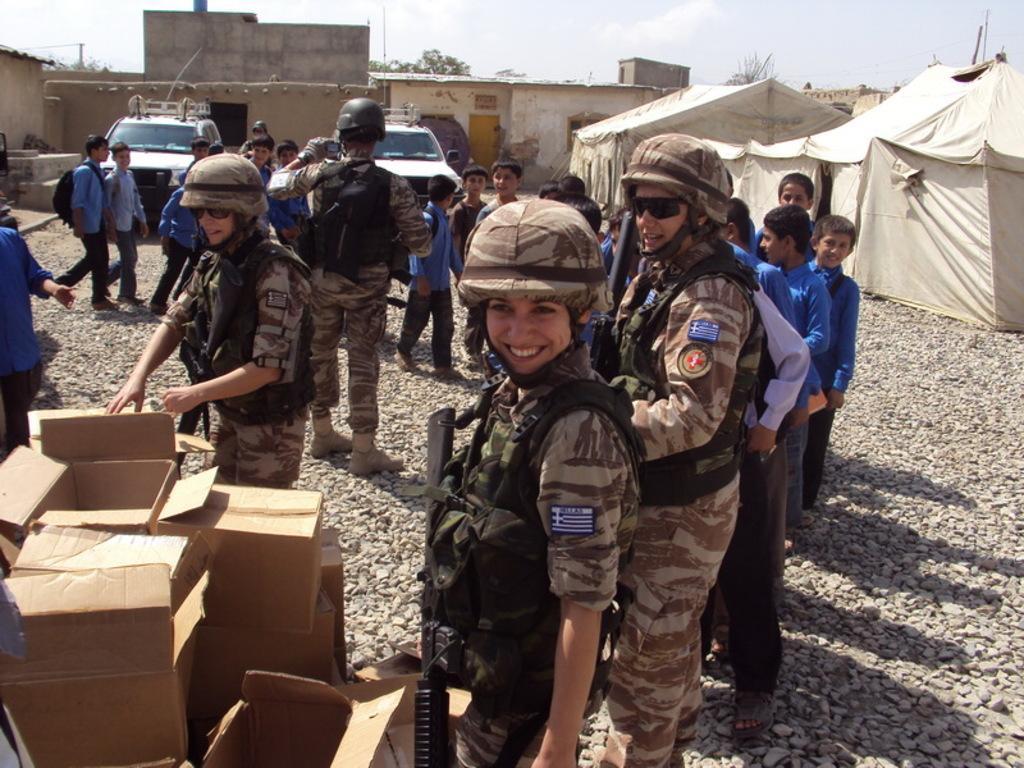Can you describe this image briefly? This image consists of many people standing on the ground. At the bottom left, there are boxes. In the background, there are two cars along with small houses. 